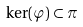<formula> <loc_0><loc_0><loc_500><loc_500>\ker ( \varphi ) \subset \pi</formula> 